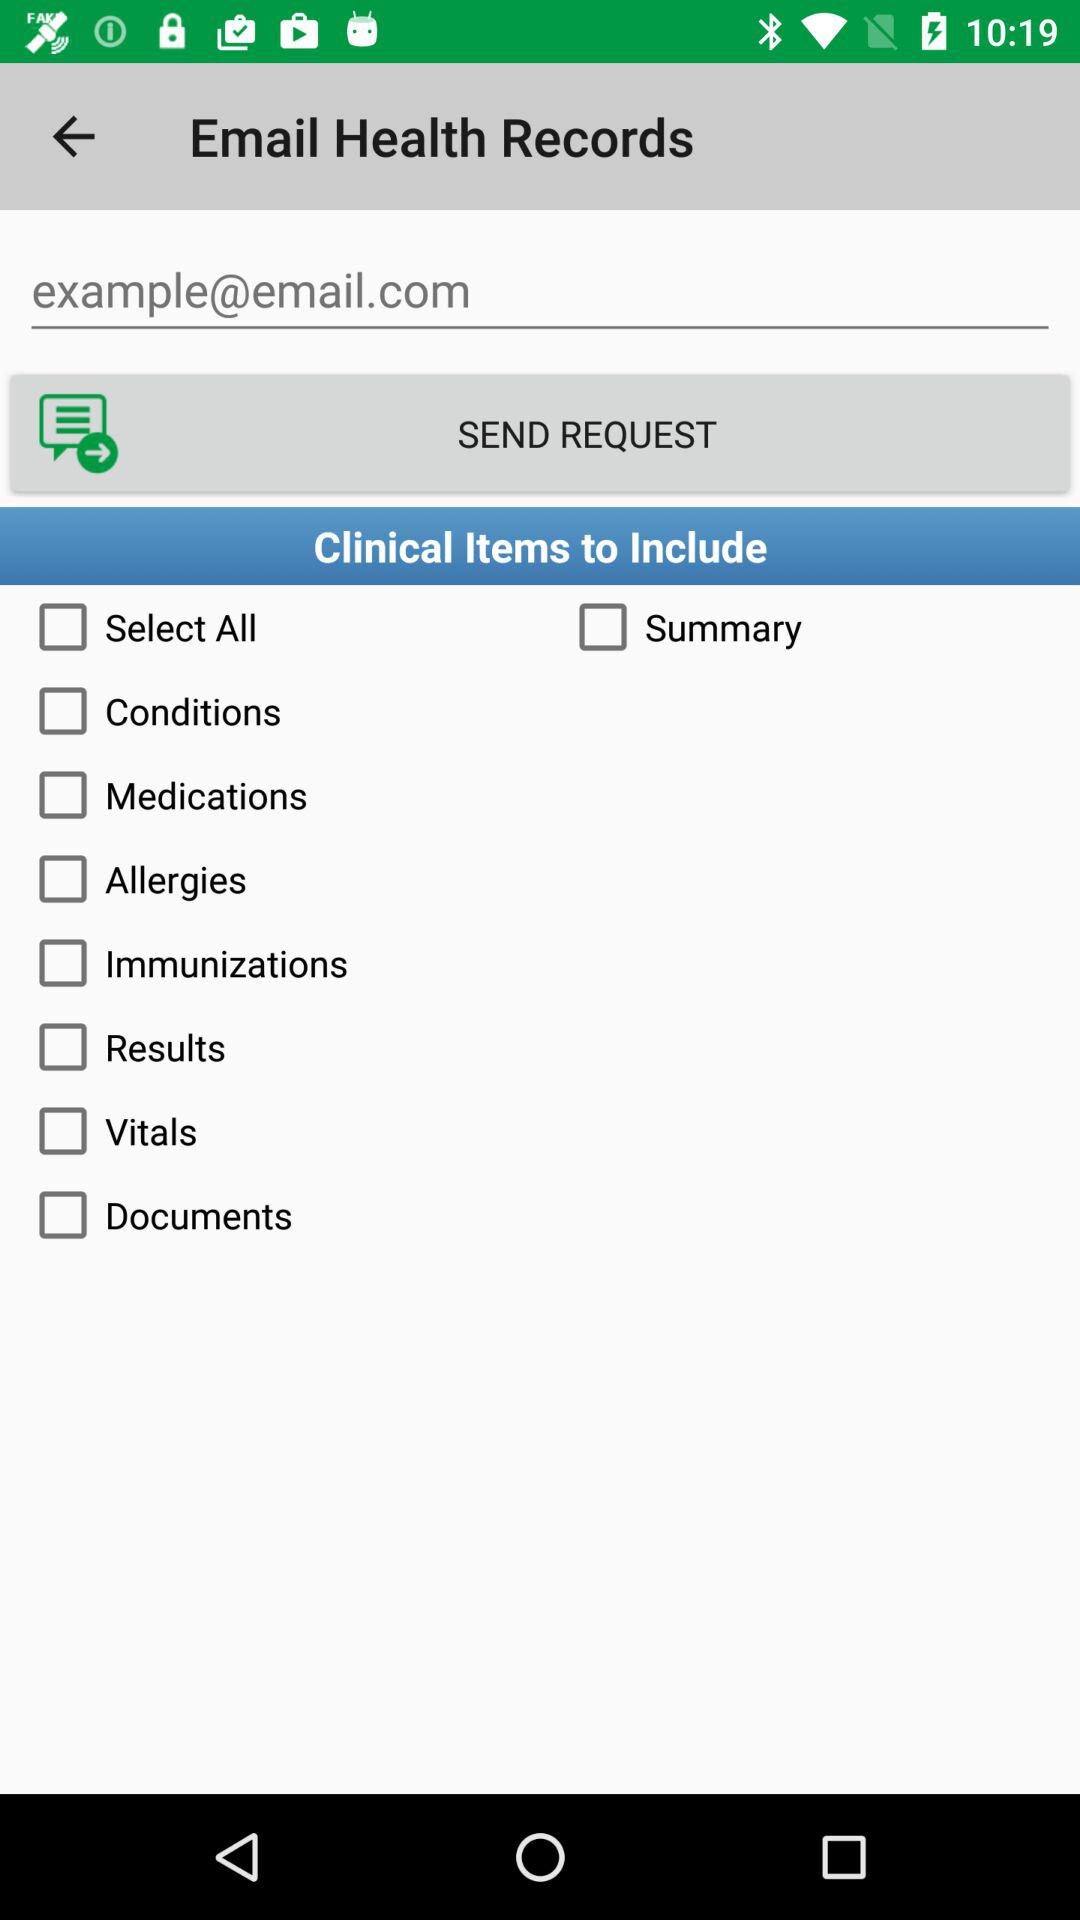What is the status of "Documents"? The status is "off". 